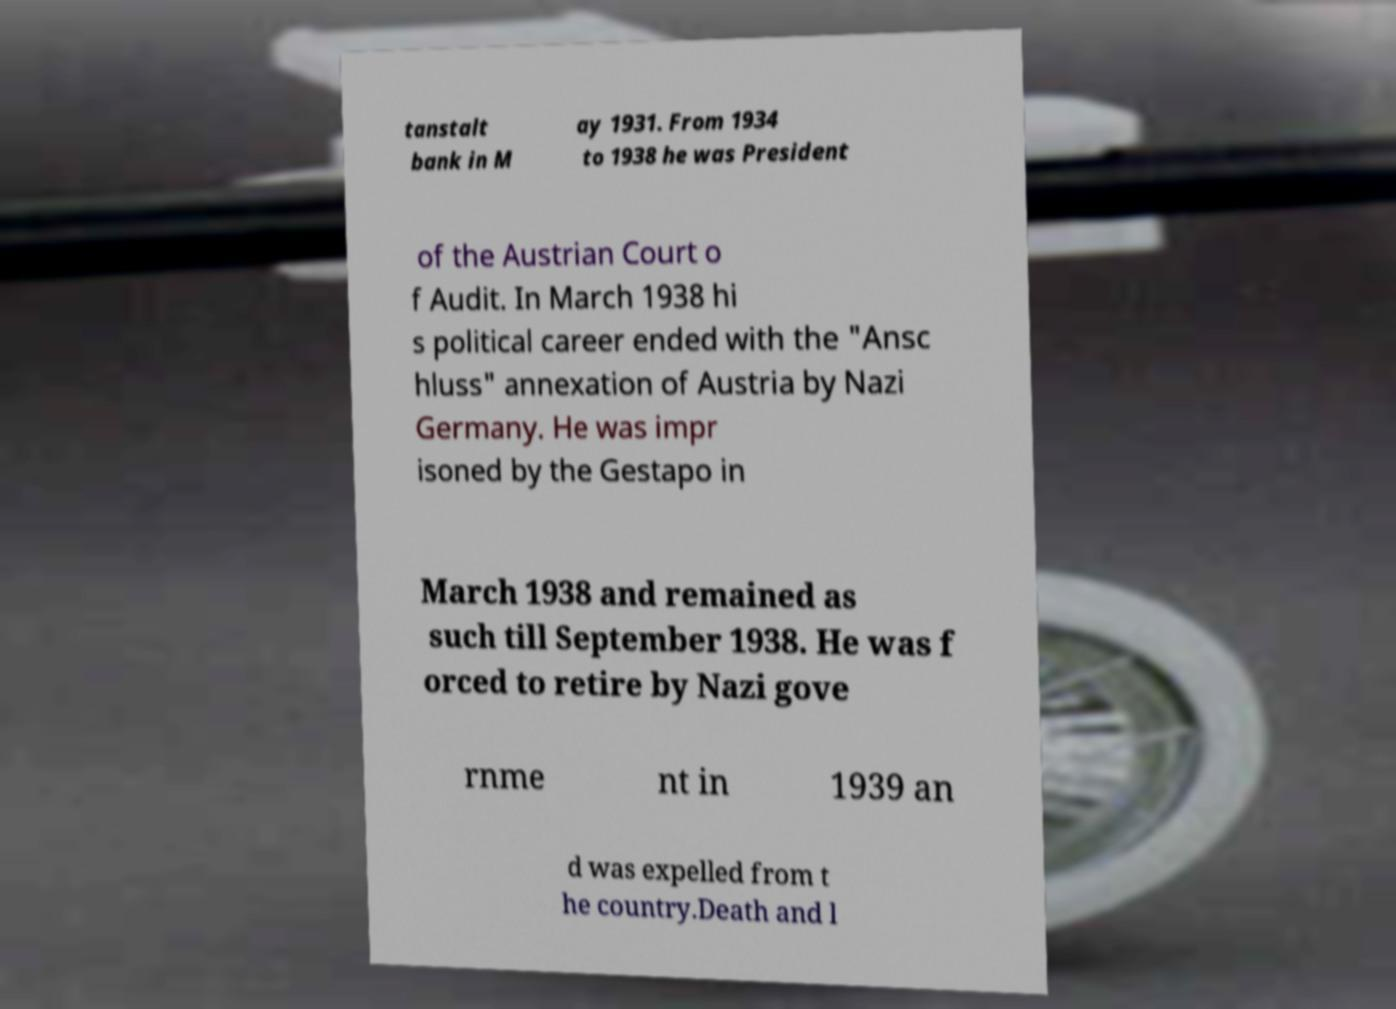Please identify and transcribe the text found in this image. tanstalt bank in M ay 1931. From 1934 to 1938 he was President of the Austrian Court o f Audit. In March 1938 hi s political career ended with the "Ansc hluss" annexation of Austria by Nazi Germany. He was impr isoned by the Gestapo in March 1938 and remained as such till September 1938. He was f orced to retire by Nazi gove rnme nt in 1939 an d was expelled from t he country.Death and l 